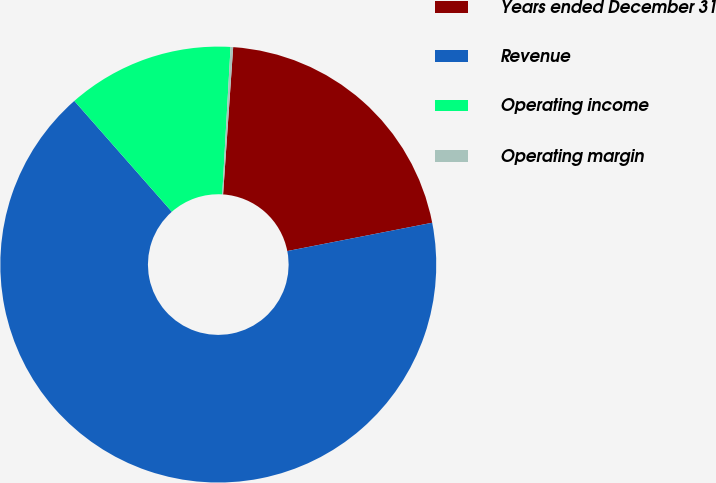Convert chart. <chart><loc_0><loc_0><loc_500><loc_500><pie_chart><fcel>Years ended December 31<fcel>Revenue<fcel>Operating income<fcel>Operating margin<nl><fcel>20.84%<fcel>66.59%<fcel>12.38%<fcel>0.19%<nl></chart> 